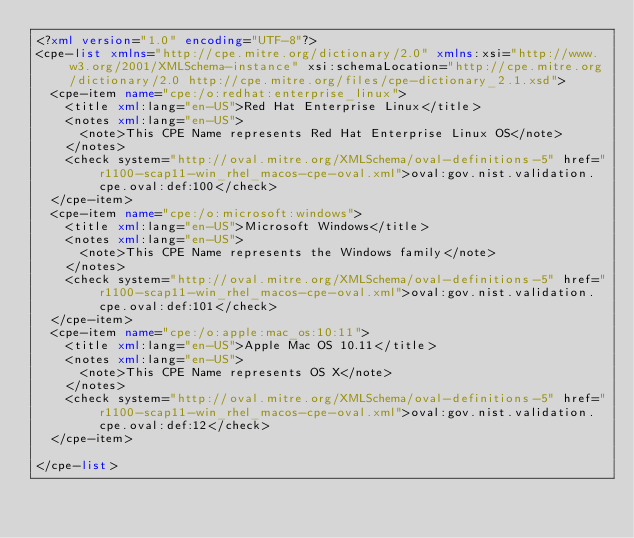<code> <loc_0><loc_0><loc_500><loc_500><_XML_><?xml version="1.0" encoding="UTF-8"?>
<cpe-list xmlns="http://cpe.mitre.org/dictionary/2.0" xmlns:xsi="http://www.w3.org/2001/XMLSchema-instance" xsi:schemaLocation="http://cpe.mitre.org/dictionary/2.0 http://cpe.mitre.org/files/cpe-dictionary_2.1.xsd">
	<cpe-item name="cpe:/o:redhat:enterprise_linux">
		<title xml:lang="en-US">Red Hat Enterprise Linux</title>
		<notes xml:lang="en-US">
			<note>This CPE Name represents Red Hat Enterprise Linux OS</note>
		</notes>
		<check system="http://oval.mitre.org/XMLSchema/oval-definitions-5" href="r1100-scap11-win_rhel_macos-cpe-oval.xml">oval:gov.nist.validation.cpe.oval:def:100</check>
	</cpe-item>
	<cpe-item name="cpe:/o:microsoft:windows">
		<title xml:lang="en-US">Microsoft Windows</title>
		<notes xml:lang="en-US">
			<note>This CPE Name represents the Windows family</note>
		</notes>
		<check system="http://oval.mitre.org/XMLSchema/oval-definitions-5" href="r1100-scap11-win_rhel_macos-cpe-oval.xml">oval:gov.nist.validation.cpe.oval:def:101</check>
	</cpe-item>
	<cpe-item name="cpe:/o:apple:mac_os:10:11">
		<title xml:lang="en-US">Apple Mac OS 10.11</title>
		<notes xml:lang="en-US">
			<note>This CPE Name represents OS X</note>
		</notes>
		<check system="http://oval.mitre.org/XMLSchema/oval-definitions-5" href="r1100-scap11-win_rhel_macos-cpe-oval.xml">oval:gov.nist.validation.cpe.oval:def:12</check>
	</cpe-item>

</cpe-list>
</code> 